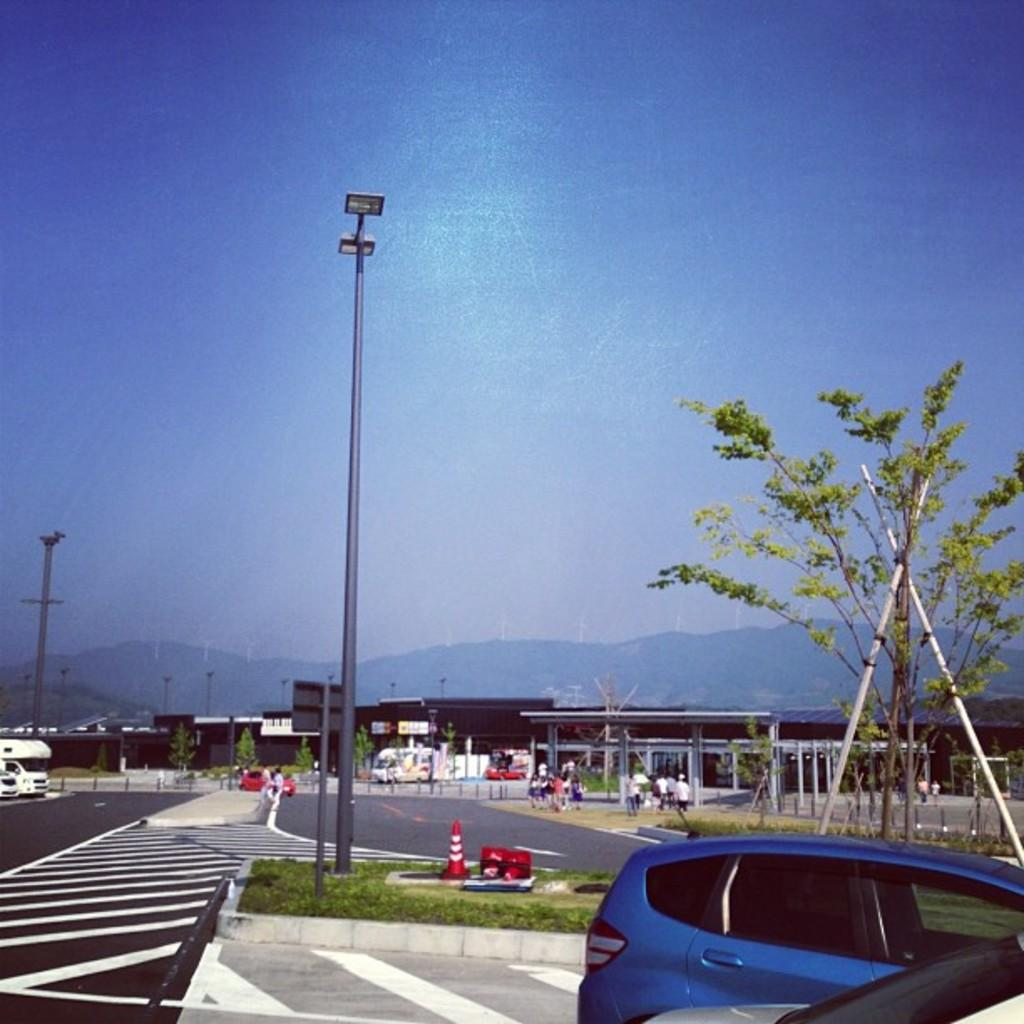What is the color of the sky in the image? The sky is blue in the image. What structures can be seen in the image? There are light poles in the image. What types of objects are present in the image? There are vehicles and people in the image. What natural elements are visible in the image? There are trees in the image. What can be seen in the background of the image? There are buildings in the distance in the image. How does the existence of the skate affect the image? There is no skate present in the image, so its existence does not affect the image. What is the increase in the number of people in the image? There is no mention of an increase in the number of people in the image; the number of people present is constant. 